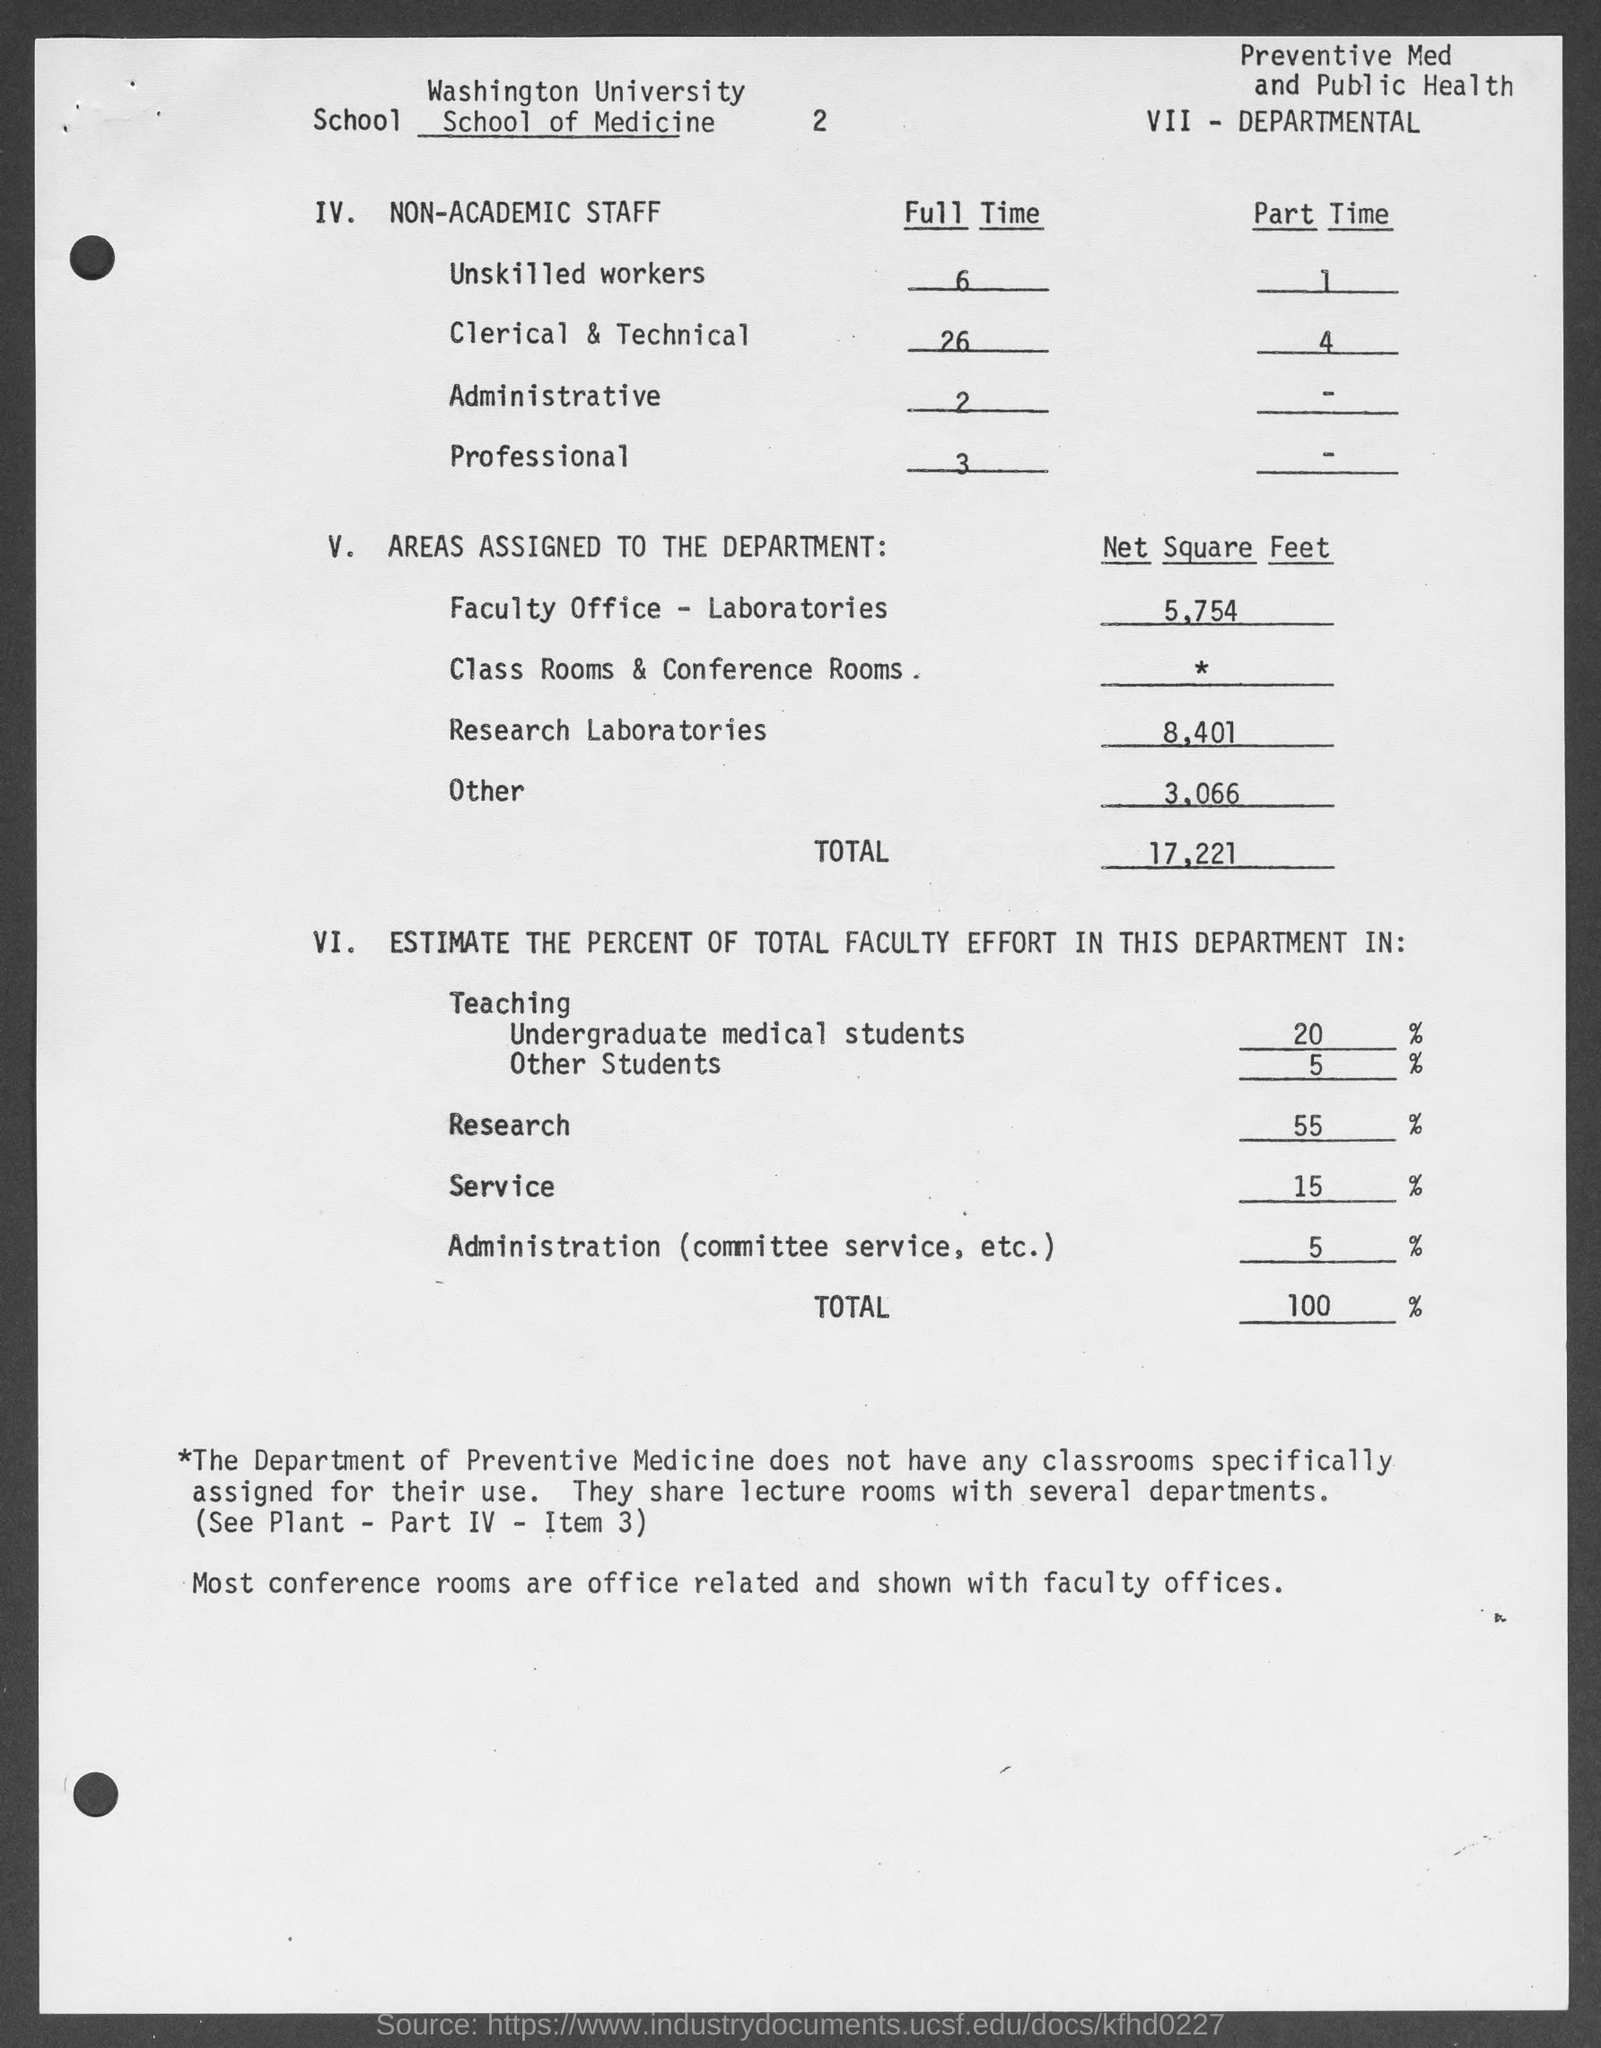Specify some key components in this picture. There are 26 clerical and technical staff members who are assigned full-time work. There are two administrative staff members who are currently performing full-time work. The area assigned to faculty office and laboratories is 5.754 square feet. The area assigned to Research Laboratories is 8,401 square feet. The Administration department is estimated to have a total faculty effort of 5% out of the total faculty effort of the institution. 